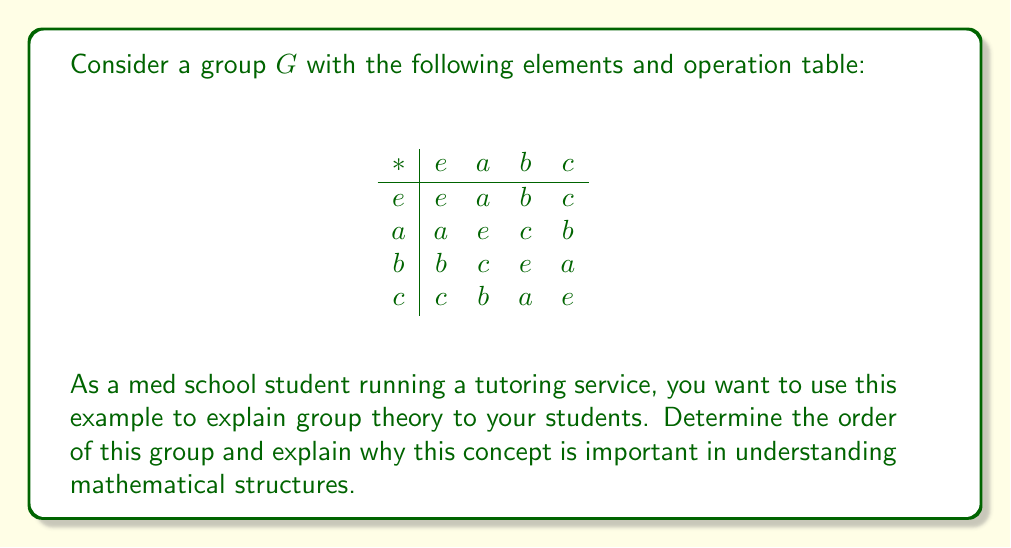Teach me how to tackle this problem. To determine the order of a finite group, we simply count the number of distinct elements in the group. In this case, we can see that the group $G$ has four elements: $e$, $a$, $b$, and $c$.

Let's break down the process:

1. Identify the elements: The group $G$ consists of the elements $\{e, a, b, c\}$.

2. Count the elements: There are 4 distinct elements in the group.

3. Verify the group properties:
   a) Closure: The operation table shows that combining any two elements always results in an element within the group.
   b) Associativity: This is assumed for the given operation.
   c) Identity element: We can see that $e$ acts as the identity element, as $e * x = x * e = x$ for all $x$ in $G$.
   d) Inverse elements: Each element has an inverse:
      - $e * e = e$ (self-inverse)
      - $a * a = e$
      - $b * b = e$
      - $c * c = e$

The order of a group is important because it helps us understand the structure and properties of the group. For example:

1. Lagrange's Theorem: The order of any subgroup of $G$ must divide the order of $G$. In this case, the possible orders of subgroups are 1, 2, and 4.

2. Cyclic subgroups: We can identify cyclic subgroups generated by each element, which is crucial for understanding the group's structure.

3. Isomorphisms: Groups of the same order may be isomorphic, which is essential for classifying and comparing different mathematical structures.

In the context of medical studies, understanding group theory can be beneficial in various ways:

1. Molecular symmetry in biochemistry and drug design
2. Analysis of genetic codes and DNA sequences
3. Medical imaging techniques that involve symmetry and transformations

By grasping these abstract concepts, students can develop critical thinking skills that are valuable in analyzing complex medical problems and research data.
Answer: The order of the given group $G$ is 4. 